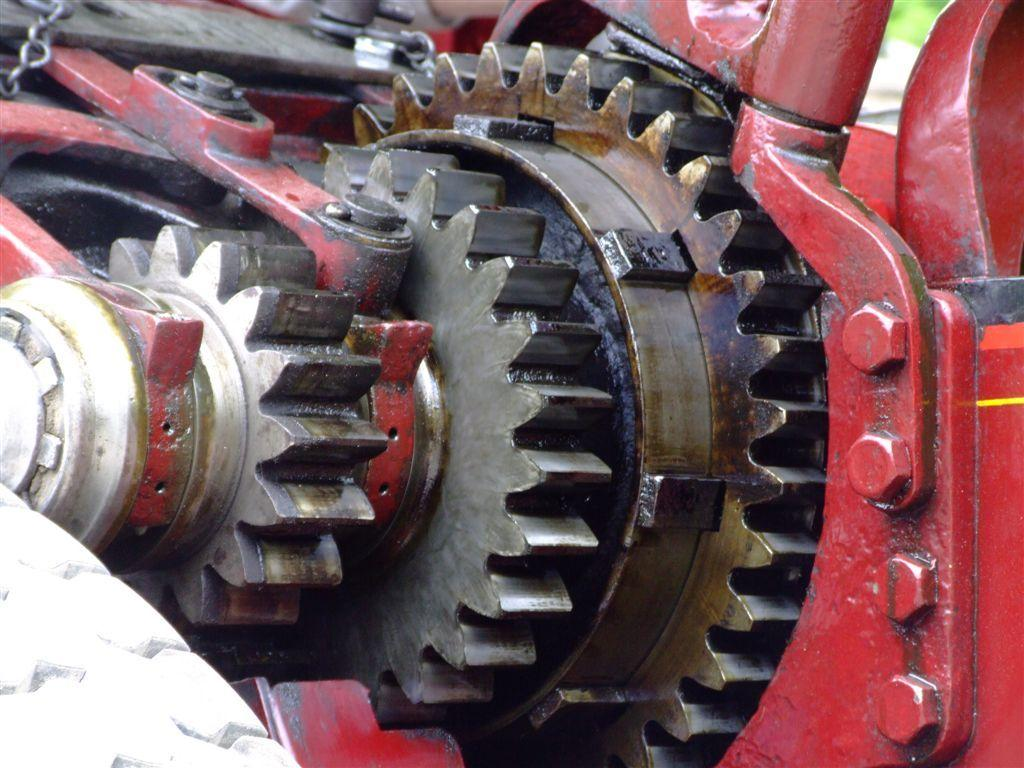What is the main subject of the picture? The main subject of the picture is a machine. What color is the machine? The machine is red in color. Can you describe any additional elements in the image? There is a chain in the left top corner of the image. What type of cable can be seen connecting the machine to the nation in the image? There is no cable connecting the machine to a nation in the image. The chain mentioned in the facts is located in the left top corner, but it is not connected to the machine or any nation. 